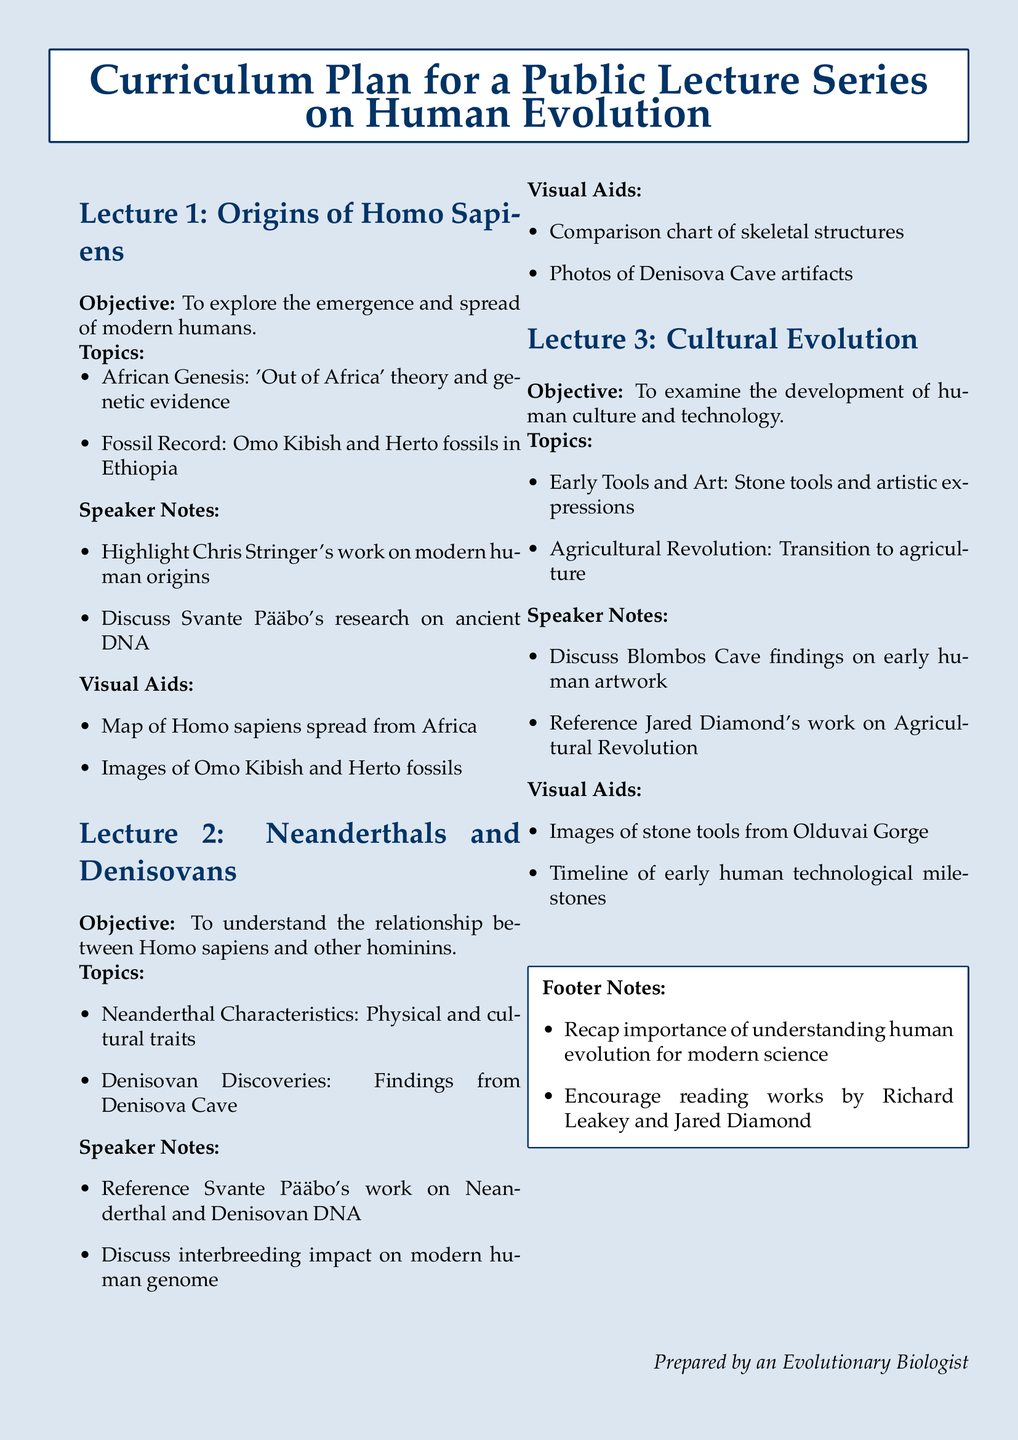What is the main topic of Lecture 1? The main topic of Lecture 1 is the emergence and spread of modern humans.
Answer: emergence and spread of modern humans Who conducted research on ancient DNA mentioned in Lecture 1? The speaker notes in Lecture 1 mention Svante Pääbo's research on ancient DNA.
Answer: Svante Pääbo What are the two fossils highlighted in Lecture 1? The fossil record discusses Omo Kibish and Herto fossils in Ethiopia.
Answer: Omo Kibish and Herto What is the objective of Lecture 3? The objective of Lecture 3 is to examine the development of human culture and technology.
Answer: development of human culture and technology Which cave's findings are discussed in relation to early human artwork? Blombos Cave findings are referenced in Lecture 3 regarding early human artwork.
Answer: Blombos Cave How many visual aids are listed for Lecture 2? There are two visual aids listed for Lecture 2: a comparison chart and photos of artifacts.
Answer: two What significant transition is examined in Lecture 3? The significant transition examined is the Agricultural Revolution.
Answer: Agricultural Revolution Who are the authors encouraged for reading in the footer notes? The footer notes encourage reading works by Richard Leakey and Jared Diamond.
Answer: Richard Leakey and Jared Diamond 